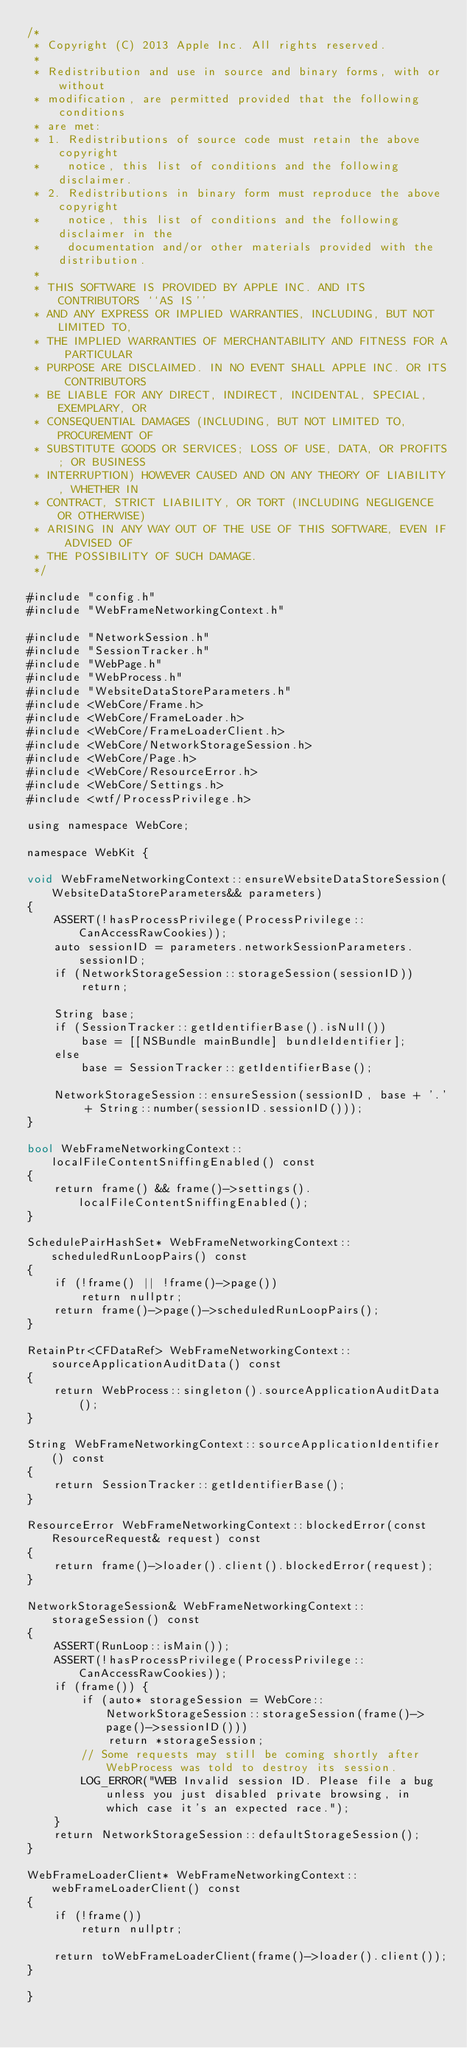Convert code to text. <code><loc_0><loc_0><loc_500><loc_500><_ObjectiveC_>/*
 * Copyright (C) 2013 Apple Inc. All rights reserved.
 *
 * Redistribution and use in source and binary forms, with or without
 * modification, are permitted provided that the following conditions
 * are met:
 * 1. Redistributions of source code must retain the above copyright
 *    notice, this list of conditions and the following disclaimer.
 * 2. Redistributions in binary form must reproduce the above copyright
 *    notice, this list of conditions and the following disclaimer in the
 *    documentation and/or other materials provided with the distribution.
 *
 * THIS SOFTWARE IS PROVIDED BY APPLE INC. AND ITS CONTRIBUTORS ``AS IS''
 * AND ANY EXPRESS OR IMPLIED WARRANTIES, INCLUDING, BUT NOT LIMITED TO,
 * THE IMPLIED WARRANTIES OF MERCHANTABILITY AND FITNESS FOR A PARTICULAR
 * PURPOSE ARE DISCLAIMED. IN NO EVENT SHALL APPLE INC. OR ITS CONTRIBUTORS
 * BE LIABLE FOR ANY DIRECT, INDIRECT, INCIDENTAL, SPECIAL, EXEMPLARY, OR
 * CONSEQUENTIAL DAMAGES (INCLUDING, BUT NOT LIMITED TO, PROCUREMENT OF
 * SUBSTITUTE GOODS OR SERVICES; LOSS OF USE, DATA, OR PROFITS; OR BUSINESS
 * INTERRUPTION) HOWEVER CAUSED AND ON ANY THEORY OF LIABILITY, WHETHER IN
 * CONTRACT, STRICT LIABILITY, OR TORT (INCLUDING NEGLIGENCE OR OTHERWISE)
 * ARISING IN ANY WAY OUT OF THE USE OF THIS SOFTWARE, EVEN IF ADVISED OF
 * THE POSSIBILITY OF SUCH DAMAGE.
 */

#include "config.h"
#include "WebFrameNetworkingContext.h"

#include "NetworkSession.h"
#include "SessionTracker.h"
#include "WebPage.h"
#include "WebProcess.h"
#include "WebsiteDataStoreParameters.h"
#include <WebCore/Frame.h>
#include <WebCore/FrameLoader.h>
#include <WebCore/FrameLoaderClient.h>
#include <WebCore/NetworkStorageSession.h>
#include <WebCore/Page.h>
#include <WebCore/ResourceError.h>
#include <WebCore/Settings.h>
#include <wtf/ProcessPrivilege.h>

using namespace WebCore;

namespace WebKit {

void WebFrameNetworkingContext::ensureWebsiteDataStoreSession(WebsiteDataStoreParameters&& parameters)
{
    ASSERT(!hasProcessPrivilege(ProcessPrivilege::CanAccessRawCookies));
    auto sessionID = parameters.networkSessionParameters.sessionID;
    if (NetworkStorageSession::storageSession(sessionID))
        return;

    String base;
    if (SessionTracker::getIdentifierBase().isNull())
        base = [[NSBundle mainBundle] bundleIdentifier];
    else
        base = SessionTracker::getIdentifierBase();

    NetworkStorageSession::ensureSession(sessionID, base + '.' + String::number(sessionID.sessionID()));
}

bool WebFrameNetworkingContext::localFileContentSniffingEnabled() const
{
    return frame() && frame()->settings().localFileContentSniffingEnabled();
}

SchedulePairHashSet* WebFrameNetworkingContext::scheduledRunLoopPairs() const
{
    if (!frame() || !frame()->page())
        return nullptr;
    return frame()->page()->scheduledRunLoopPairs();
}

RetainPtr<CFDataRef> WebFrameNetworkingContext::sourceApplicationAuditData() const
{
    return WebProcess::singleton().sourceApplicationAuditData();
}

String WebFrameNetworkingContext::sourceApplicationIdentifier() const
{
    return SessionTracker::getIdentifierBase();
}

ResourceError WebFrameNetworkingContext::blockedError(const ResourceRequest& request) const
{
    return frame()->loader().client().blockedError(request);
}

NetworkStorageSession& WebFrameNetworkingContext::storageSession() const
{
    ASSERT(RunLoop::isMain());
    ASSERT(!hasProcessPrivilege(ProcessPrivilege::CanAccessRawCookies));
    if (frame()) {
        if (auto* storageSession = WebCore::NetworkStorageSession::storageSession(frame()->page()->sessionID()))
            return *storageSession;
        // Some requests may still be coming shortly after WebProcess was told to destroy its session.
        LOG_ERROR("WEB Invalid session ID. Please file a bug unless you just disabled private browsing, in which case it's an expected race.");
    }
    return NetworkStorageSession::defaultStorageSession();
}

WebFrameLoaderClient* WebFrameNetworkingContext::webFrameLoaderClient() const
{
    if (!frame())
        return nullptr;

    return toWebFrameLoaderClient(frame()->loader().client());
}

}
</code> 